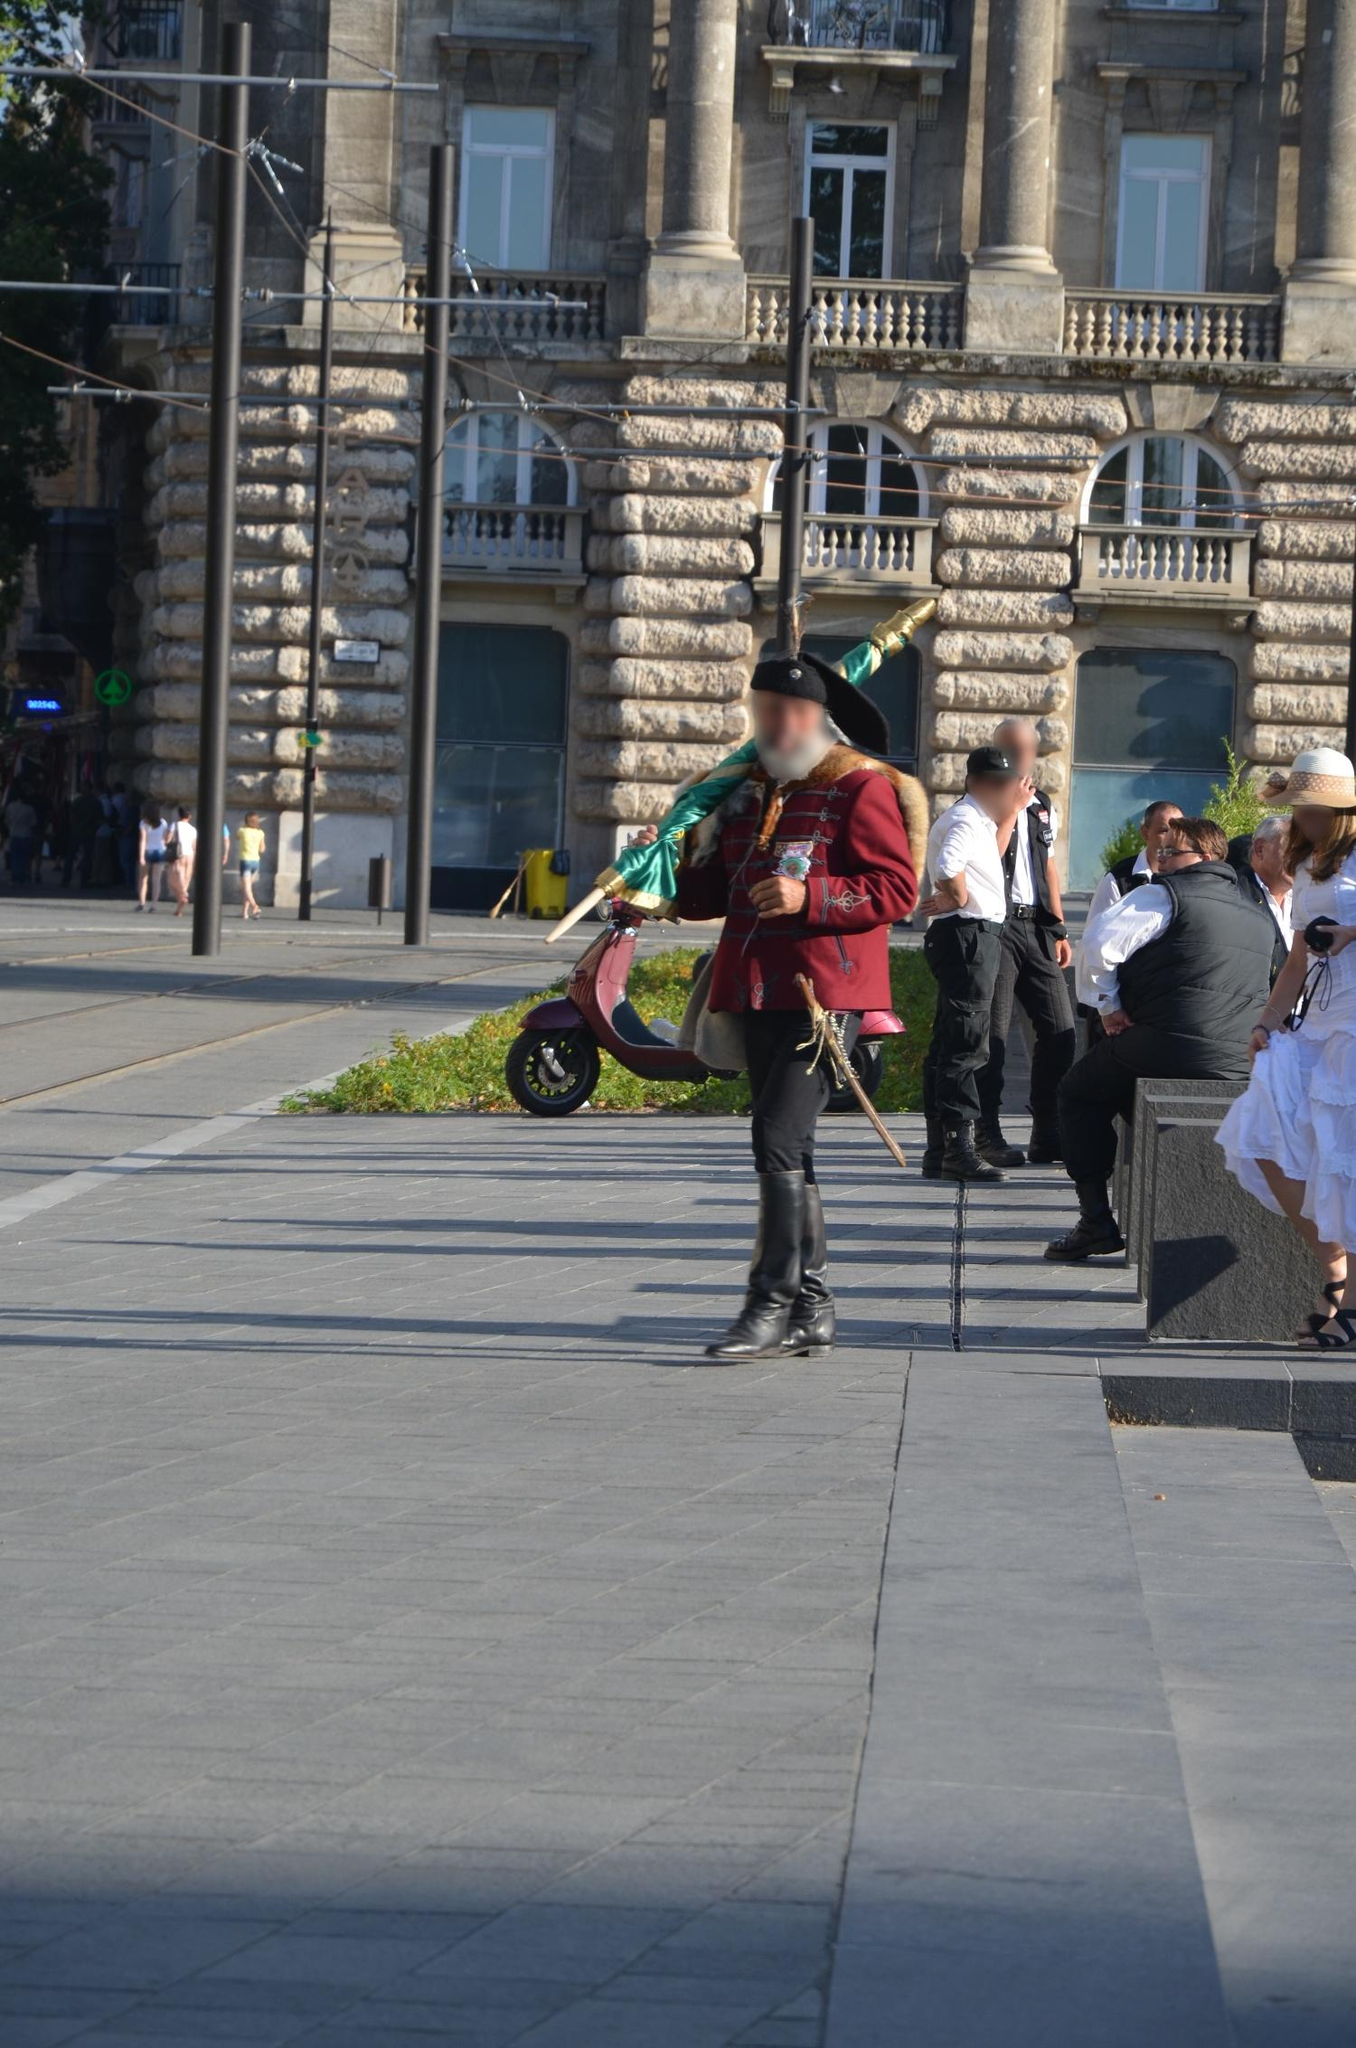What do you see happening in this image? The image captures a vivid scene of a man dressed in a traditional Hungarian Hussar uniform, commonly associated with cultural and historical celebrations in Hungary. The uniform is richly detailed, adorned with decorative elements, and complements the symbolic relevance of the green flag he carries, often seen in national festivities. He strides confidently along a sidewalk in what appears to be a bustling urban setting, possibly in Budapest, given the architectural style of the buildings and the visible tram system, a common sight in this historic city. This portrayal not only reflects a preservation of heritage but also shows the daily life where traditional elements seamlessly blend with modern urban settings. 